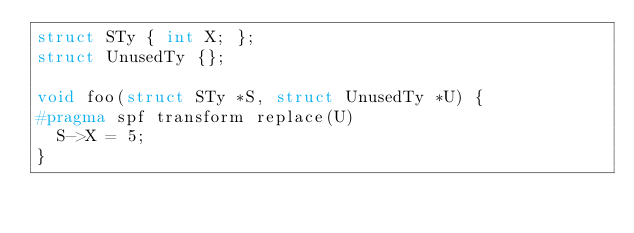Convert code to text. <code><loc_0><loc_0><loc_500><loc_500><_C_>struct STy { int X; };
struct UnusedTy {};

void foo(struct STy *S, struct UnusedTy *U) {
#pragma spf transform replace(U)
  S->X = 5;
}
</code> 